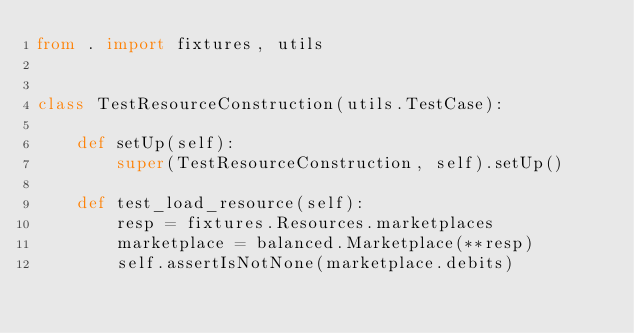<code> <loc_0><loc_0><loc_500><loc_500><_Python_>from . import fixtures, utils


class TestResourceConstruction(utils.TestCase):

    def setUp(self):
        super(TestResourceConstruction, self).setUp()

    def test_load_resource(self):
        resp = fixtures.Resources.marketplaces
        marketplace = balanced.Marketplace(**resp)
        self.assertIsNotNone(marketplace.debits)
</code> 